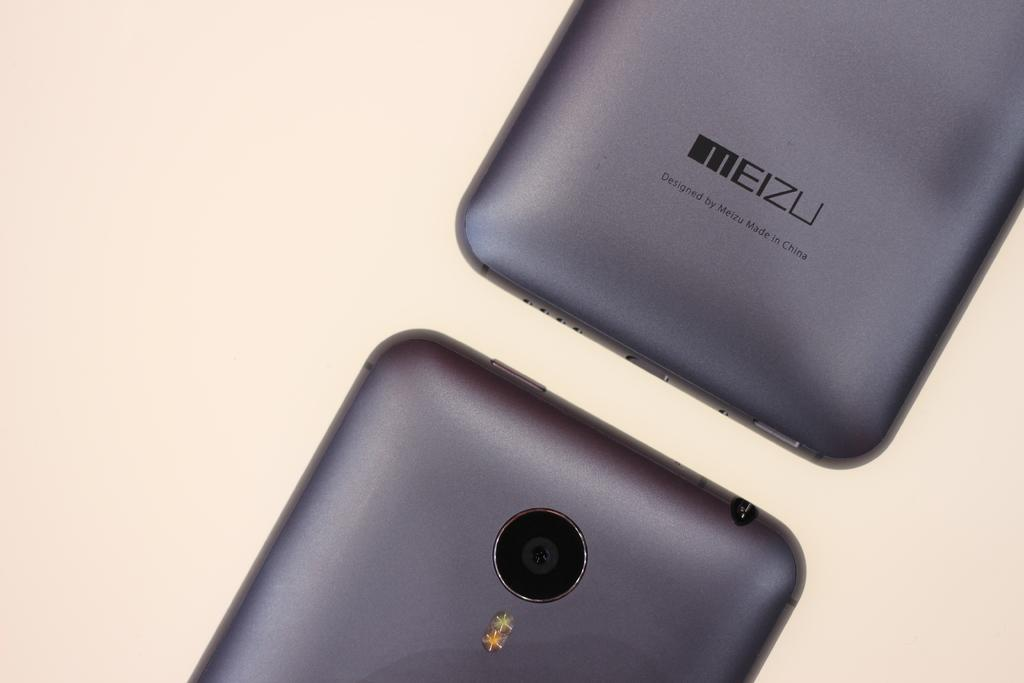<image>
Provide a brief description of the given image. The rear bottom of a meizu smart phone says Designed by Meizu Made in China and it above the top of another phone. 